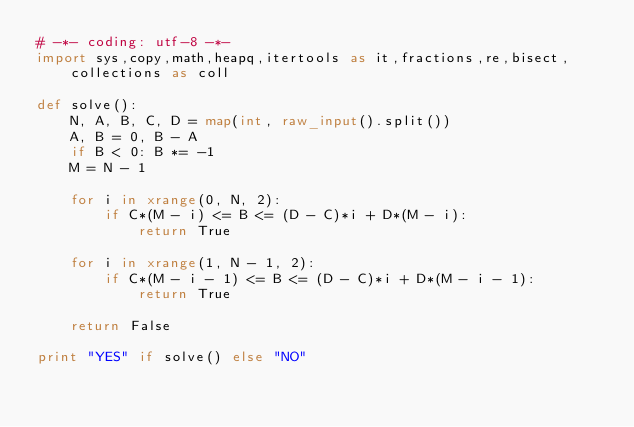<code> <loc_0><loc_0><loc_500><loc_500><_Python_># -*- coding: utf-8 -*-
import sys,copy,math,heapq,itertools as it,fractions,re,bisect,collections as coll

def solve():
    N, A, B, C, D = map(int, raw_input().split()) 
    A, B = 0, B - A
    if B < 0: B *= -1
    M = N - 1

    for i in xrange(0, N, 2):
        if C*(M - i) <= B <= (D - C)*i + D*(M - i):
            return True

    for i in xrange(1, N - 1, 2):
        if C*(M - i - 1) <= B <= (D - C)*i + D*(M - i - 1):
            return True

    return False

print "YES" if solve() else "NO"

</code> 